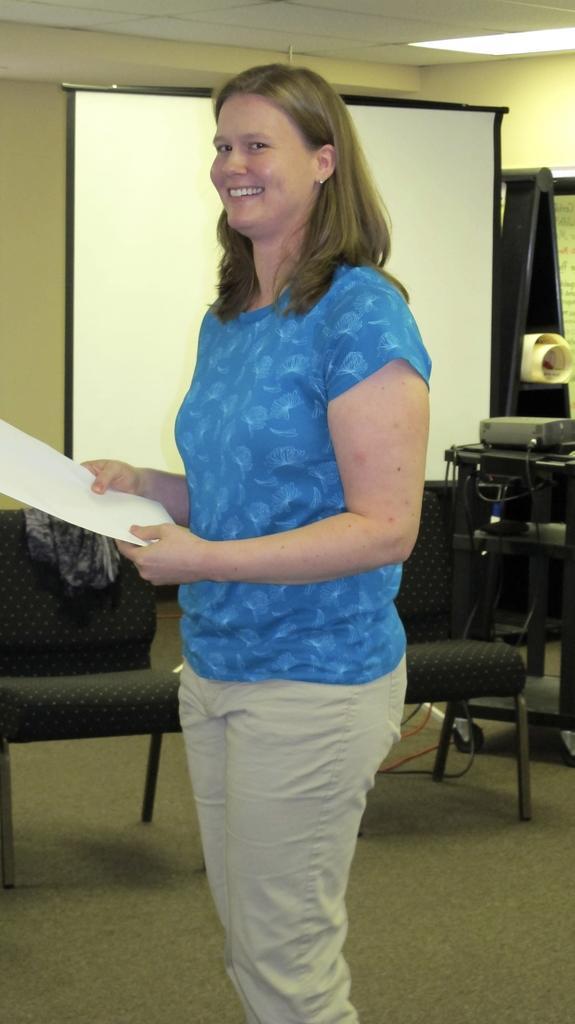Please provide a concise description of this image. In this image I can see a person standing wearing blue shirt, cream pant and holding few papers. Background I can see few chairs, a projector, a screen and the wall is in cream color. 